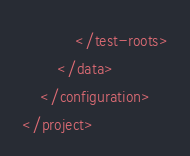<code> <loc_0><loc_0><loc_500><loc_500><_XML_>            </test-roots>
        </data>
    </configuration>
</project>
</code> 